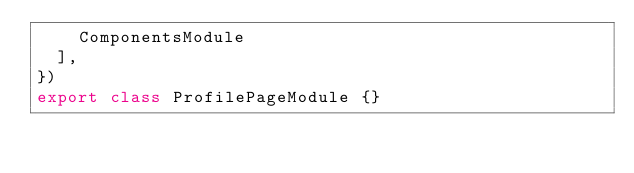Convert code to text. <code><loc_0><loc_0><loc_500><loc_500><_TypeScript_>    ComponentsModule
  ],
})
export class ProfilePageModule {}
</code> 